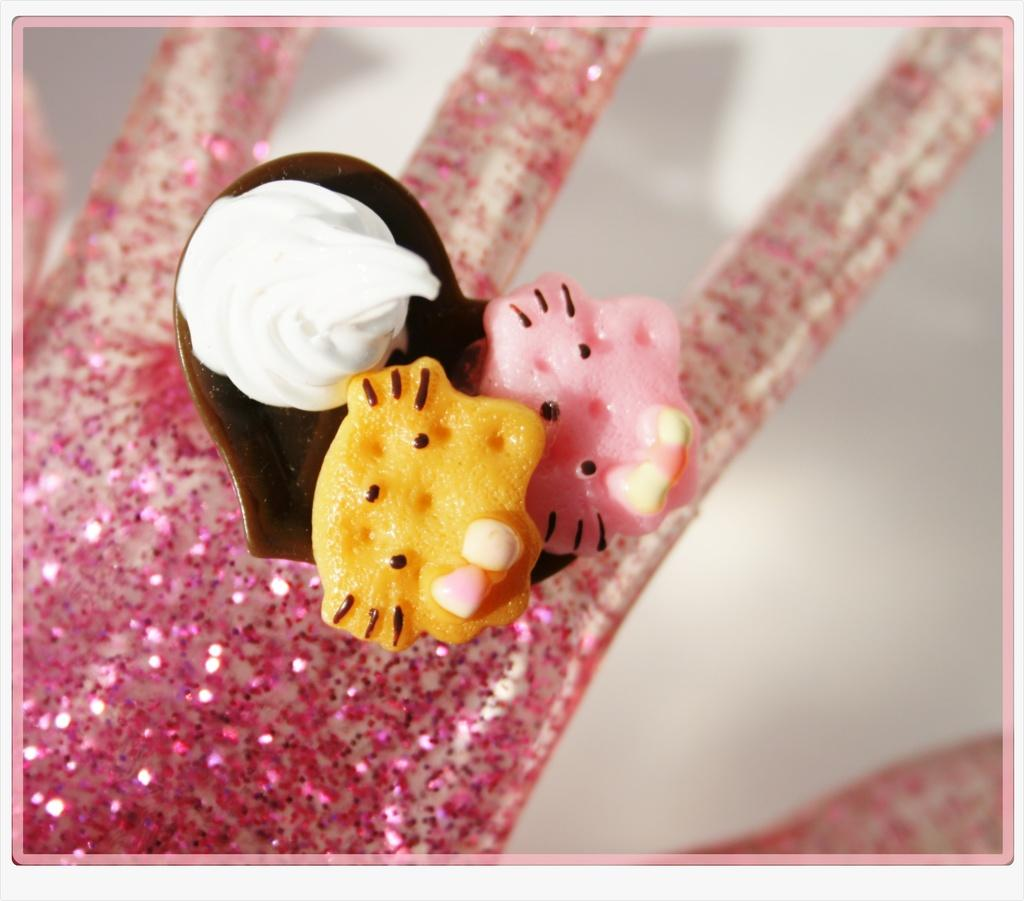What is the main object in the image? There is an artificial glitter hand in the image. What is placed on top of the glitter hand? There is a cupcake on top of the glitter hand. What other items can be seen in the image? There are jellies in the image. Reasoning: Let' Let's think step by step in order to produce the conversation. We start by identifying the main subject in the image, which is the artificial glitter hand. Then, we describe what is placed on top of the glitter hand, which is a cupcake. Finally, we mention other items visible in the image, which are the jellies. Each question is designed to elicit a specific detail about the image that is known from the provided facts. Absurd Question/Answer: How does the glitter hand balance the cupcake and jellies at the same time? The image does not show the glitter hand balancing anything, as it is an artificial hand and not capable of balancing objects. 